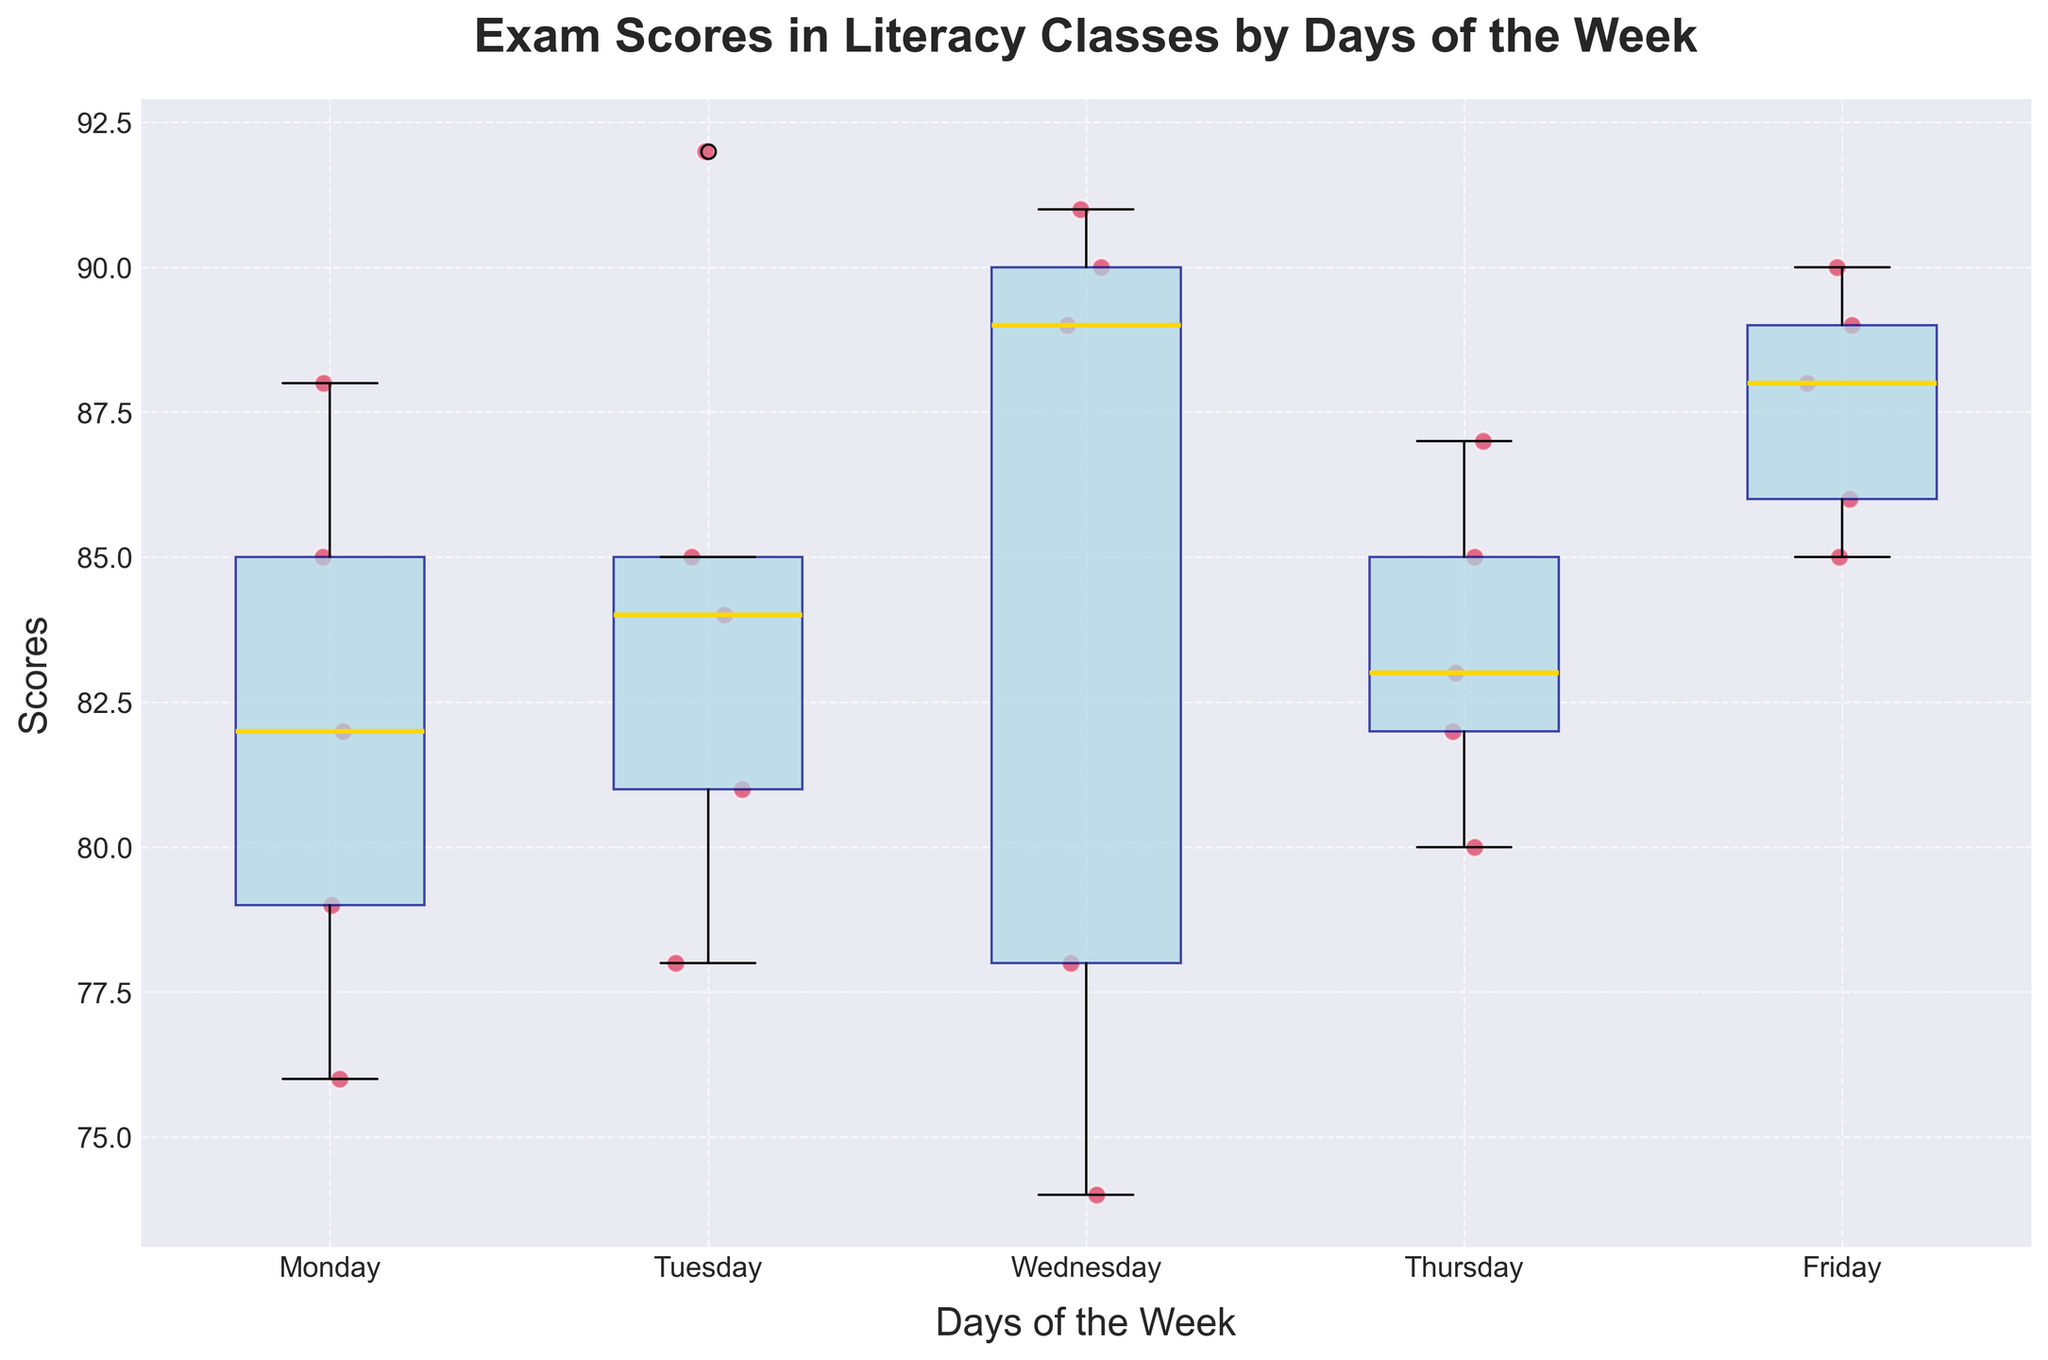What's the title of the plot? The title of the plot is typically displayed at the top of the figure in large, bold text. In this case, it is "Exam Scores in Literacy Classes by Days of the Week".
Answer: Exam Scores in Literacy Classes by Days of the Week What do the colors of the box plots and scatter points represent? The colors help differentiate between different elements of the box plot. The box plots are light blue with dark blue edges, representing the statistical distribution, while the scatter points are crimson red, representing individual student scores.
Answer: Light blue and dark blue for box plots, crimson for scatter points How many data points are there for each day? The scatter points represent individual scores, and by counting them, we see there are five scatter points for each day of the week, indicating five scores per day.
Answer: 5 Which day has the highest median score? The median is represented by the gold line within each box plot. By comparing the positions of these lines across all days, we see Friday's gold line is the highest.
Answer: Friday Which day has the widest interquartile range (IQR)? The IQR is represented by the height of the box in the box plot. By visually comparing the heights, we see Tuesday has the widest IQR.
Answer: Tuesday What's the range of scores on Wednesday? The range is the difference between the highest and lowest points. On Wednesday, the highest scatter point is 91, and the lowest is 74, giving a range of 91 - 74 = 17.
Answer: 17 How does the variability of scores on Monday compare to that on Friday? Variability can be estimated using the IQR and the spread of scatter points. Monday has a smaller IQR, indicating less variability, while Friday has a larger number of outliers, indicating greater variability.
Answer: Less variable on Monday, more variable on Friday Which day has the lowest minimum score? The minimum score is the smallest scatter point. By visual inspection, Wednesday has the lowest minimum score of 74.
Answer: Wednesday Is there any day where all students scored above 75? By inspecting the lowest scatter point for each day, we see that on Friday, the lowest score is 85, which is above 75.
Answer: Friday What's the median score on Tuesday? The gold line in Tuesday's box plot represents the median score. By visual inspection, this line is at 84.
Answer: 84 